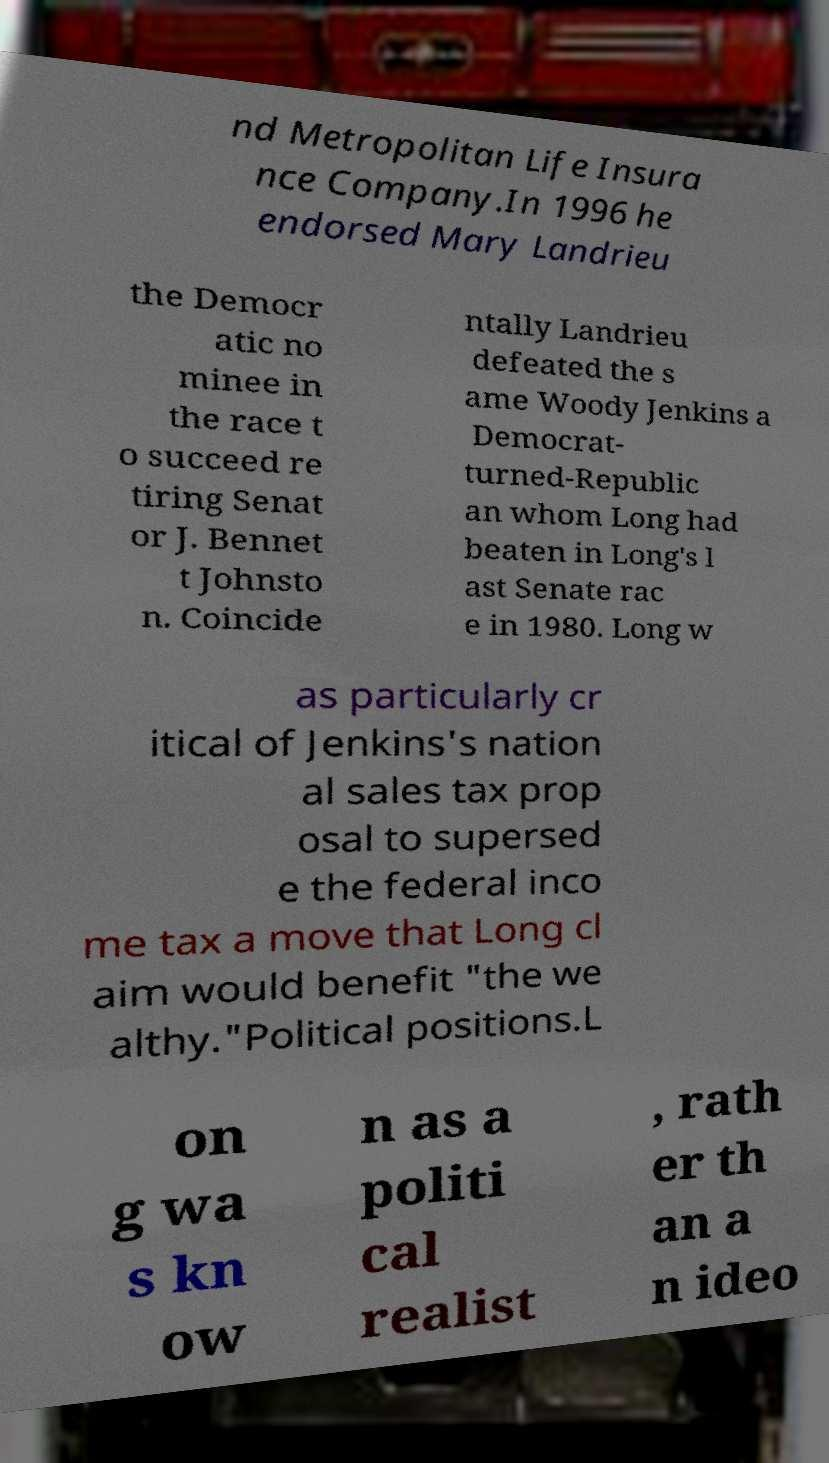Could you extract and type out the text from this image? nd Metropolitan Life Insura nce Company.In 1996 he endorsed Mary Landrieu the Democr atic no minee in the race t o succeed re tiring Senat or J. Bennet t Johnsto n. Coincide ntally Landrieu defeated the s ame Woody Jenkins a Democrat- turned-Republic an whom Long had beaten in Long's l ast Senate rac e in 1980. Long w as particularly cr itical of Jenkins's nation al sales tax prop osal to supersed e the federal inco me tax a move that Long cl aim would benefit "the we althy."Political positions.L on g wa s kn ow n as a politi cal realist , rath er th an a n ideo 